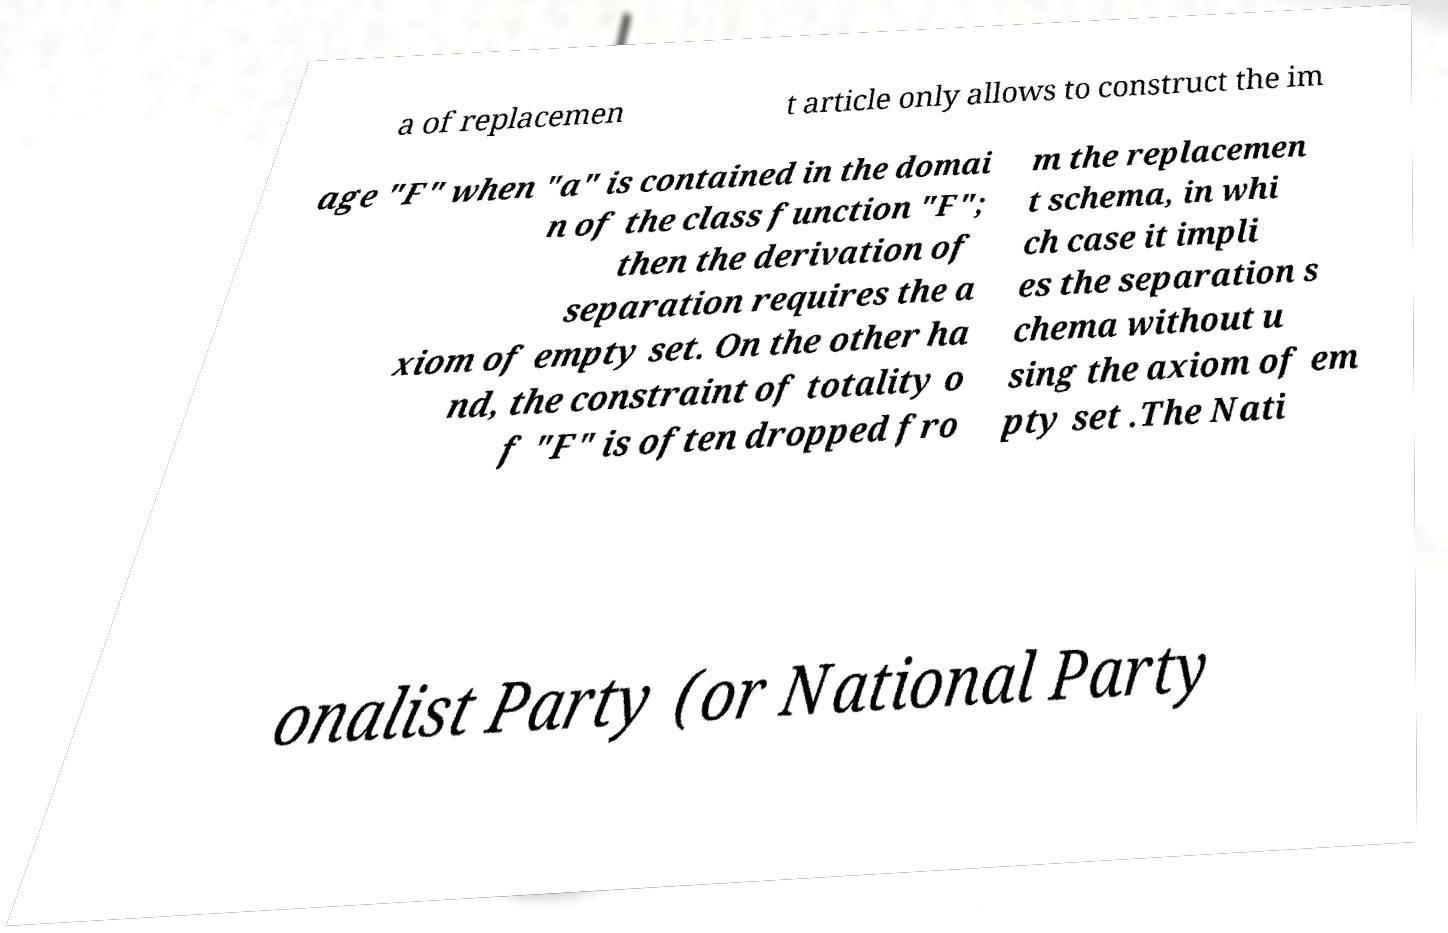Could you extract and type out the text from this image? a of replacemen t article only allows to construct the im age "F" when "a" is contained in the domai n of the class function "F"; then the derivation of separation requires the a xiom of empty set. On the other ha nd, the constraint of totality o f "F" is often dropped fro m the replacemen t schema, in whi ch case it impli es the separation s chema without u sing the axiom of em pty set .The Nati onalist Party (or National Party 